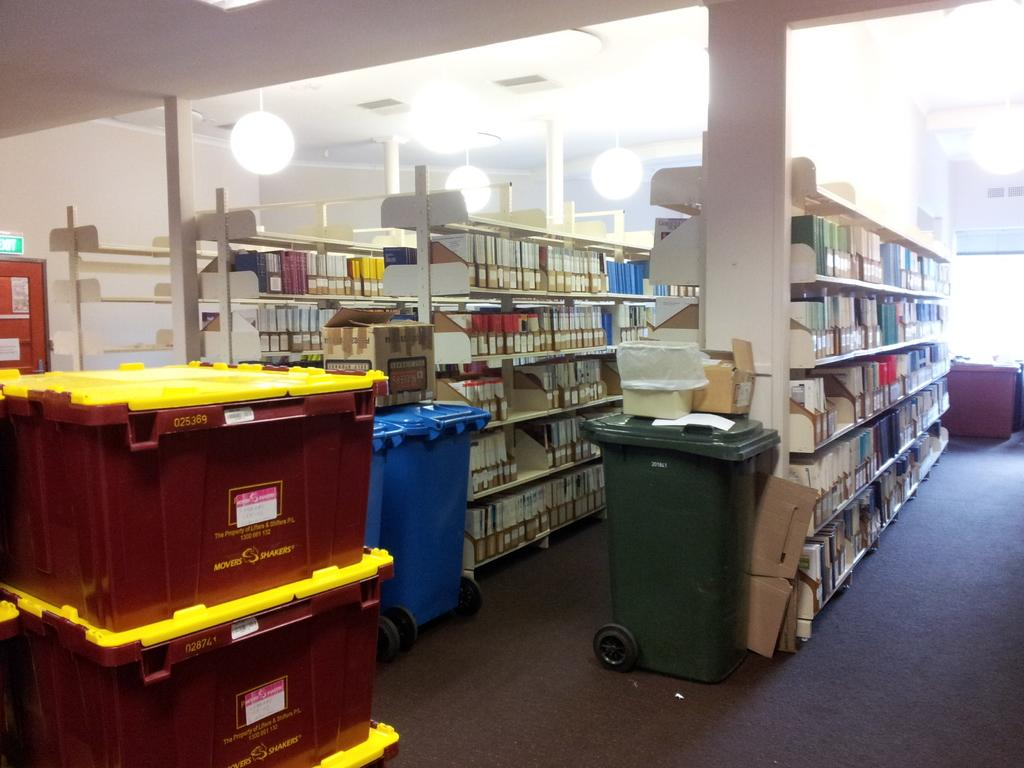<image>
Summarize the visual content of the image. Red, hard-sided boxes with yellow lids made by Movers Shakers were stacked and waiting to be unloaded and replenish the shelves. 